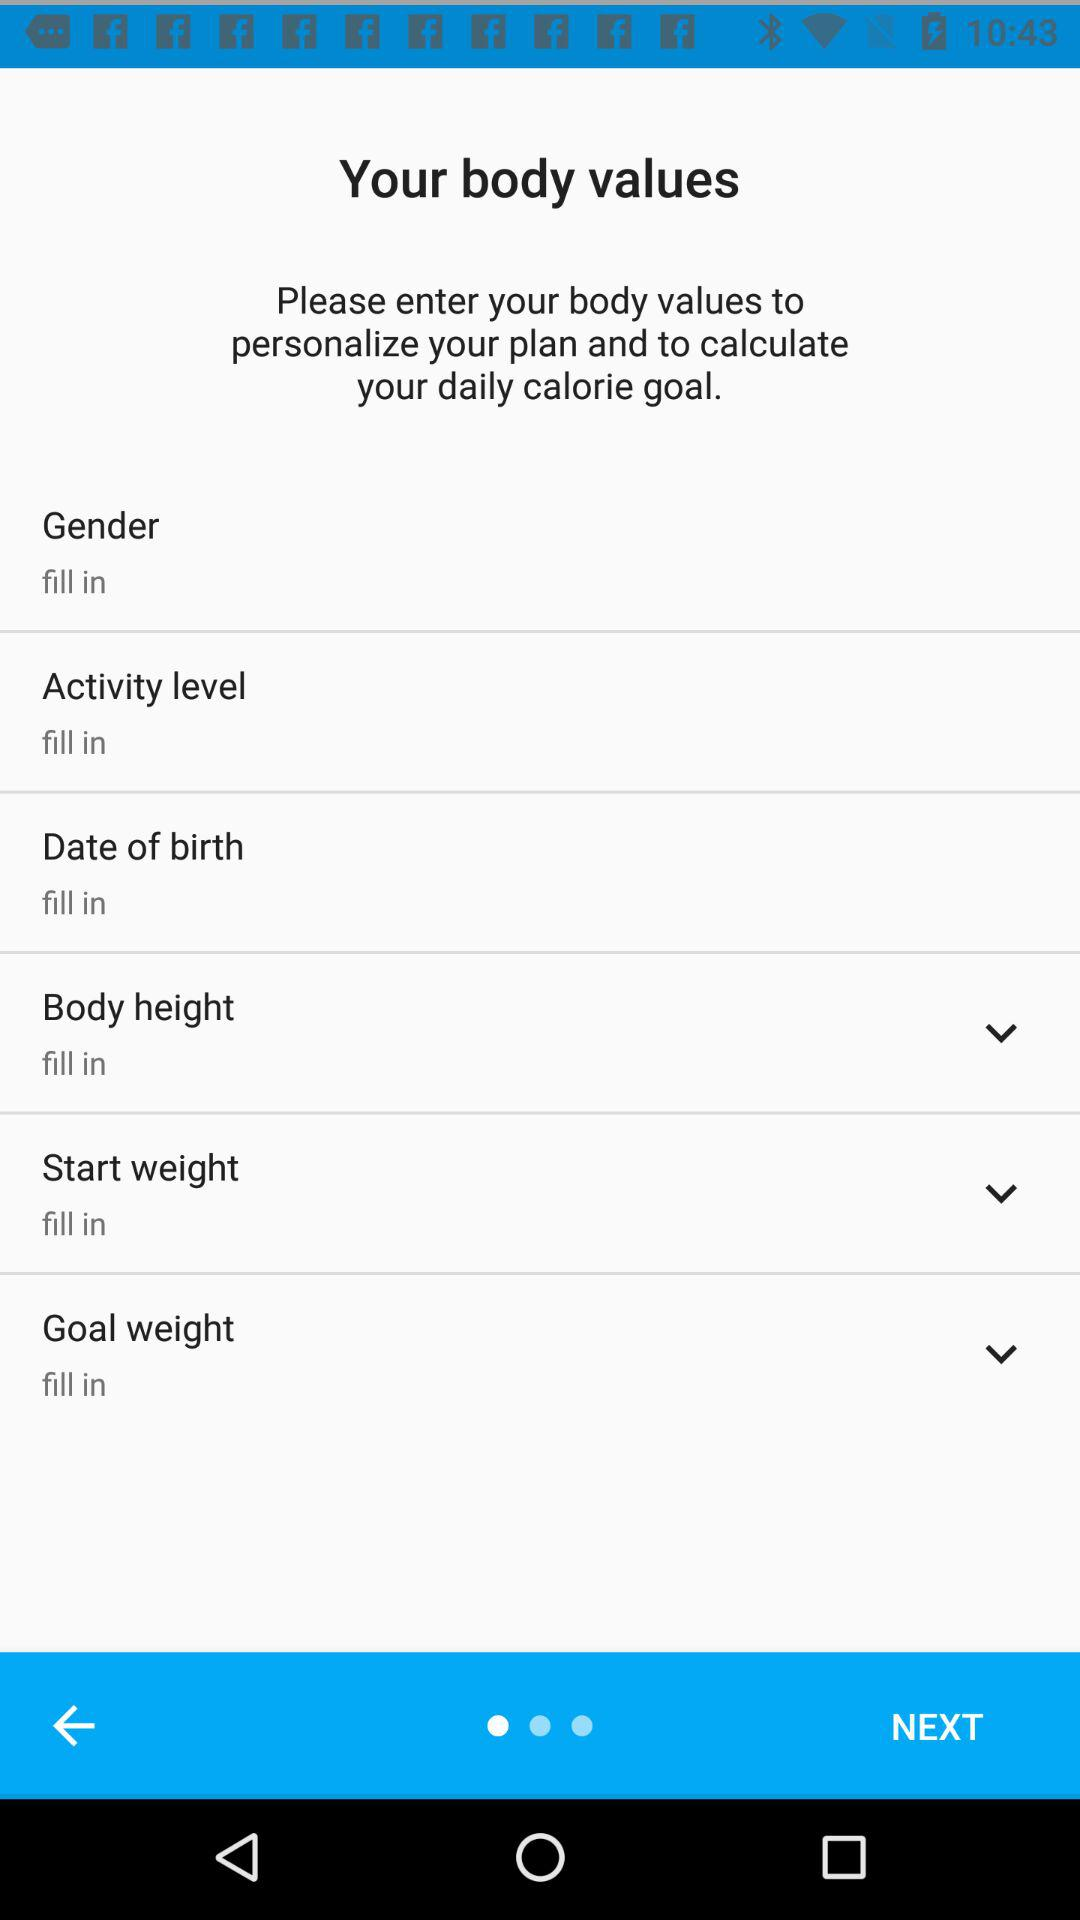How many fields are there in the login form?
Answer the question using a single word or phrase. 2 